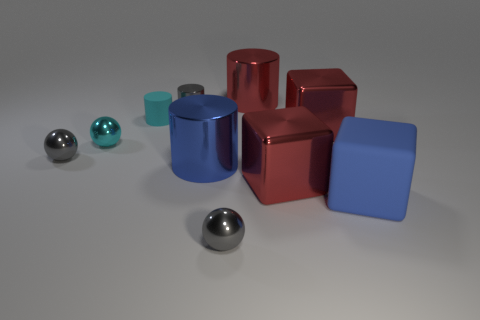Subtract all red blocks. How many blocks are left? 1 Subtract all tiny cyan spheres. How many spheres are left? 2 Subtract all cylinders. How many objects are left? 6 Subtract all yellow cubes. Subtract all yellow balls. How many cubes are left? 3 Subtract all yellow cubes. How many red cylinders are left? 1 Subtract all big red cubes. Subtract all gray metal cylinders. How many objects are left? 7 Add 7 big red metal objects. How many big red metal objects are left? 10 Add 3 small cyan metal spheres. How many small cyan metal spheres exist? 4 Subtract 0 brown cubes. How many objects are left? 10 